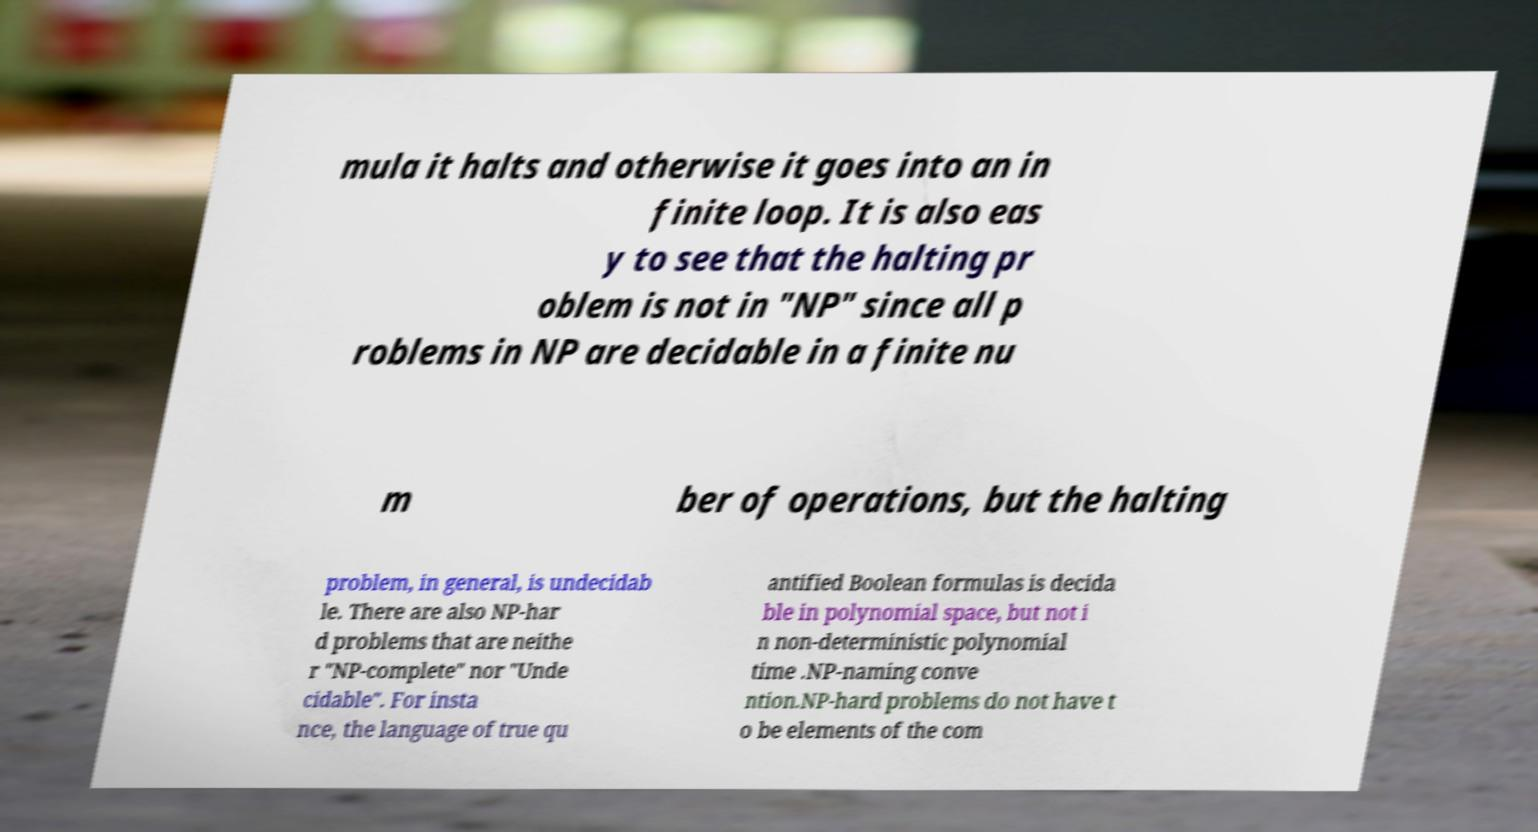What messages or text are displayed in this image? I need them in a readable, typed format. mula it halts and otherwise it goes into an in finite loop. It is also eas y to see that the halting pr oblem is not in "NP" since all p roblems in NP are decidable in a finite nu m ber of operations, but the halting problem, in general, is undecidab le. There are also NP-har d problems that are neithe r "NP-complete" nor "Unde cidable". For insta nce, the language of true qu antified Boolean formulas is decida ble in polynomial space, but not i n non-deterministic polynomial time .NP-naming conve ntion.NP-hard problems do not have t o be elements of the com 